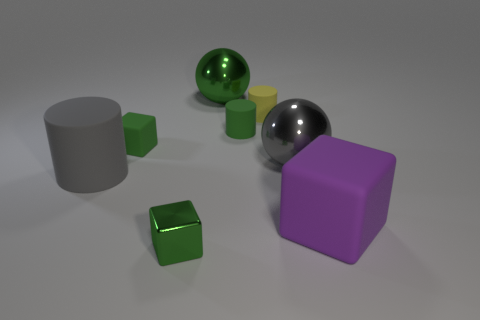How many cyan objects have the same shape as the large purple object?
Your response must be concise. 0. What material is the gray thing on the left side of the green cylinder to the left of the purple object?
Offer a very short reply. Rubber. What shape is the shiny object that is the same color as the small shiny cube?
Offer a terse response. Sphere. Is there a tiny gray object that has the same material as the big green ball?
Provide a short and direct response. No. The gray metallic object is what shape?
Give a very brief answer. Sphere. What number of cylinders are there?
Offer a very short reply. 3. There is a metal ball that is right of the green metal thing behind the tiny green metallic cube; what color is it?
Provide a short and direct response. Gray. What is the color of the shiny object that is the same size as the green cylinder?
Provide a short and direct response. Green. Is there a rubber thing of the same color as the tiny metallic block?
Offer a terse response. Yes. Is there a large shiny ball?
Keep it short and to the point. Yes. 